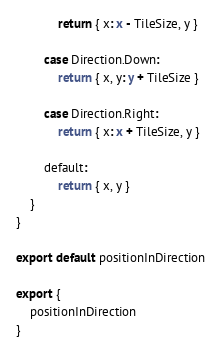Convert code to text. <code><loc_0><loc_0><loc_500><loc_500><_TypeScript_>			return { x: x - TileSize, y }

		case Direction.Down:
			return { x, y: y + TileSize }

		case Direction.Right:
			return { x: x + TileSize, y }

		default:
			return { x, y }
	}
}

export default positionInDirection

export {
	positionInDirection
}
</code> 